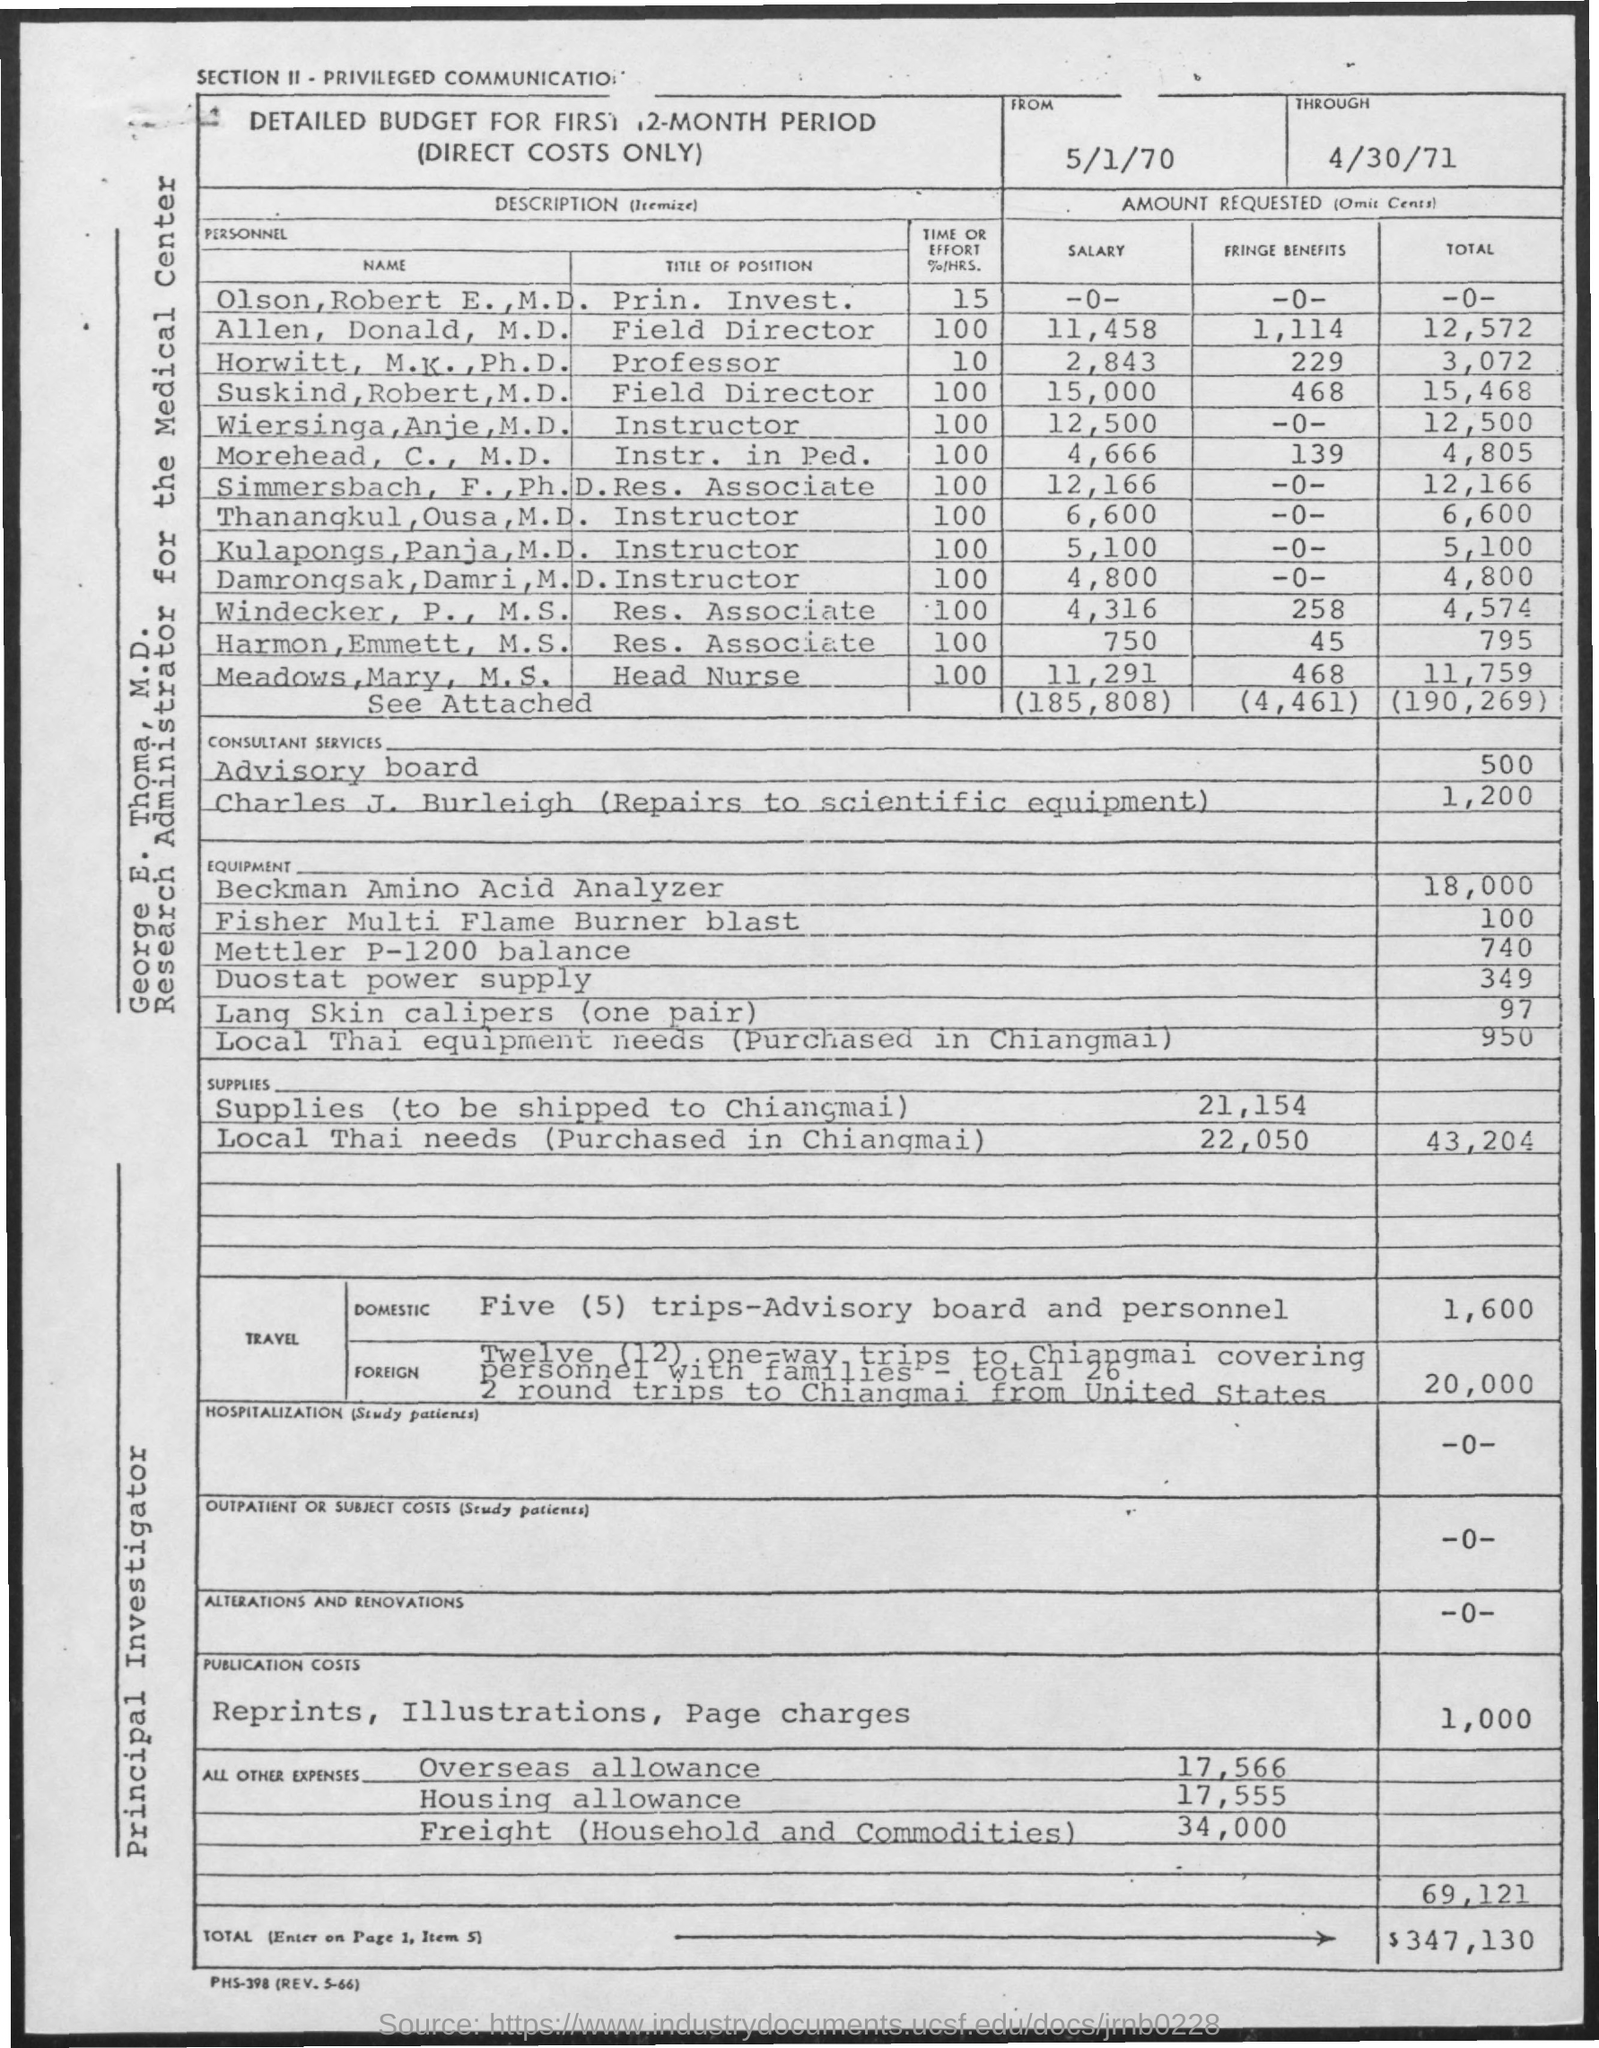Point out several critical features in this image. George E. Thoma is designated as a Research Administrator for the Medical Center. 